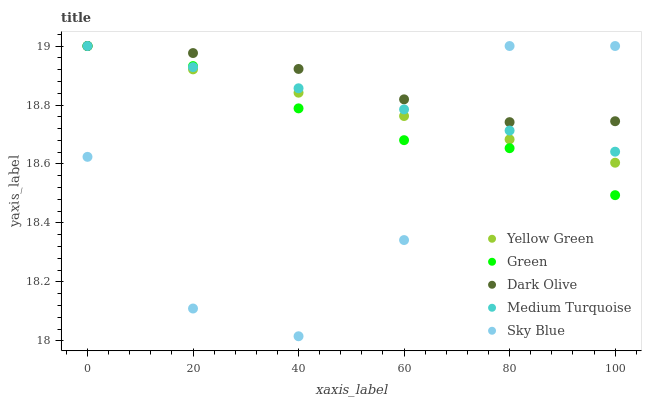Does Sky Blue have the minimum area under the curve?
Answer yes or no. Yes. Does Dark Olive have the maximum area under the curve?
Answer yes or no. Yes. Does Green have the minimum area under the curve?
Answer yes or no. No. Does Green have the maximum area under the curve?
Answer yes or no. No. Is Medium Turquoise the smoothest?
Answer yes or no. Yes. Is Sky Blue the roughest?
Answer yes or no. Yes. Is Dark Olive the smoothest?
Answer yes or no. No. Is Dark Olive the roughest?
Answer yes or no. No. Does Sky Blue have the lowest value?
Answer yes or no. Yes. Does Green have the lowest value?
Answer yes or no. No. Does Medium Turquoise have the highest value?
Answer yes or no. Yes. Does Sky Blue intersect Green?
Answer yes or no. Yes. Is Sky Blue less than Green?
Answer yes or no. No. Is Sky Blue greater than Green?
Answer yes or no. No. 